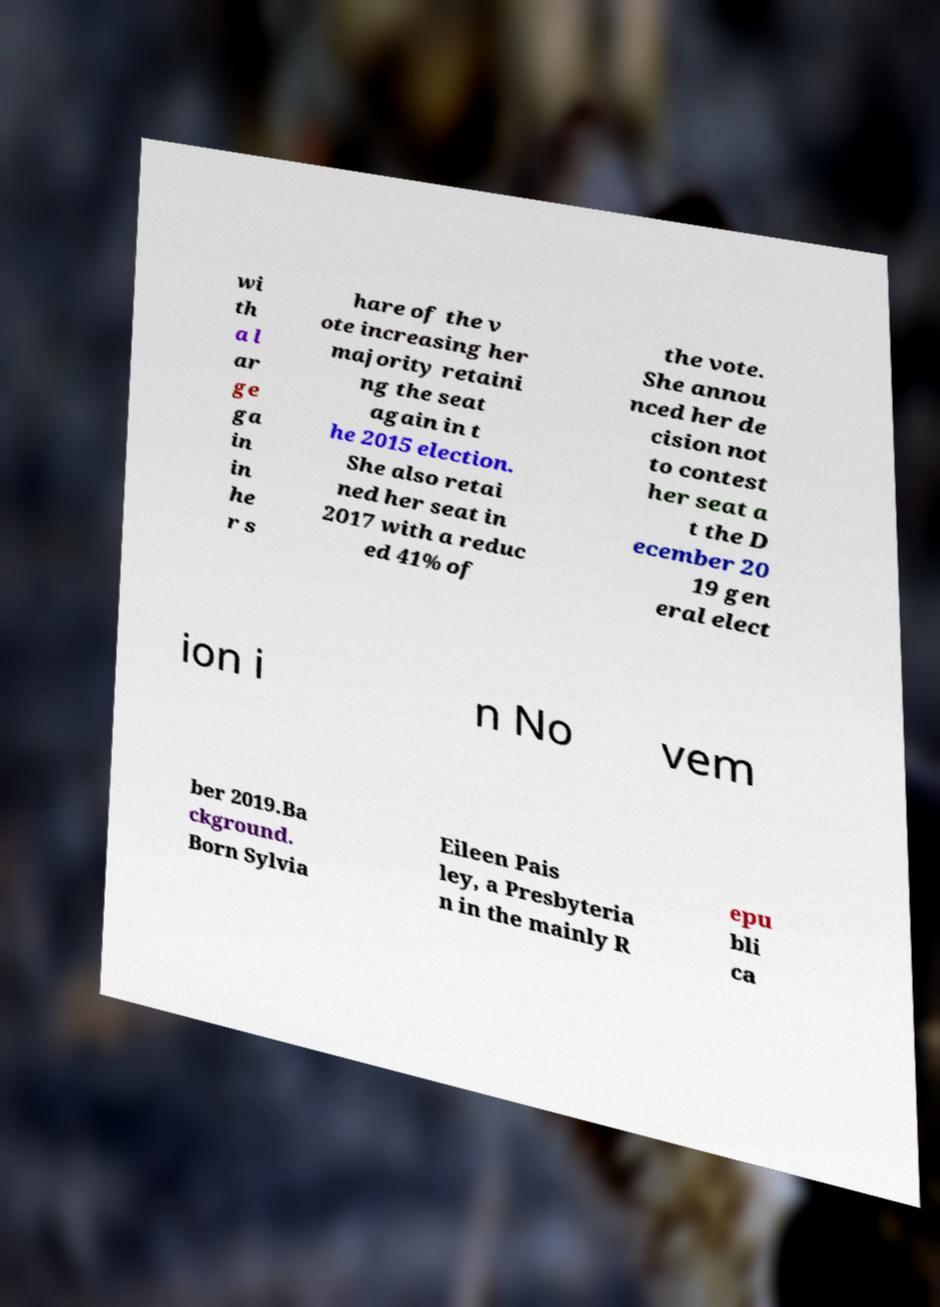For documentation purposes, I need the text within this image transcribed. Could you provide that? wi th a l ar ge ga in in he r s hare of the v ote increasing her majority retaini ng the seat again in t he 2015 election. She also retai ned her seat in 2017 with a reduc ed 41% of the vote. She annou nced her de cision not to contest her seat a t the D ecember 20 19 gen eral elect ion i n No vem ber 2019.Ba ckground. Born Sylvia Eileen Pais ley, a Presbyteria n in the mainly R epu bli ca 